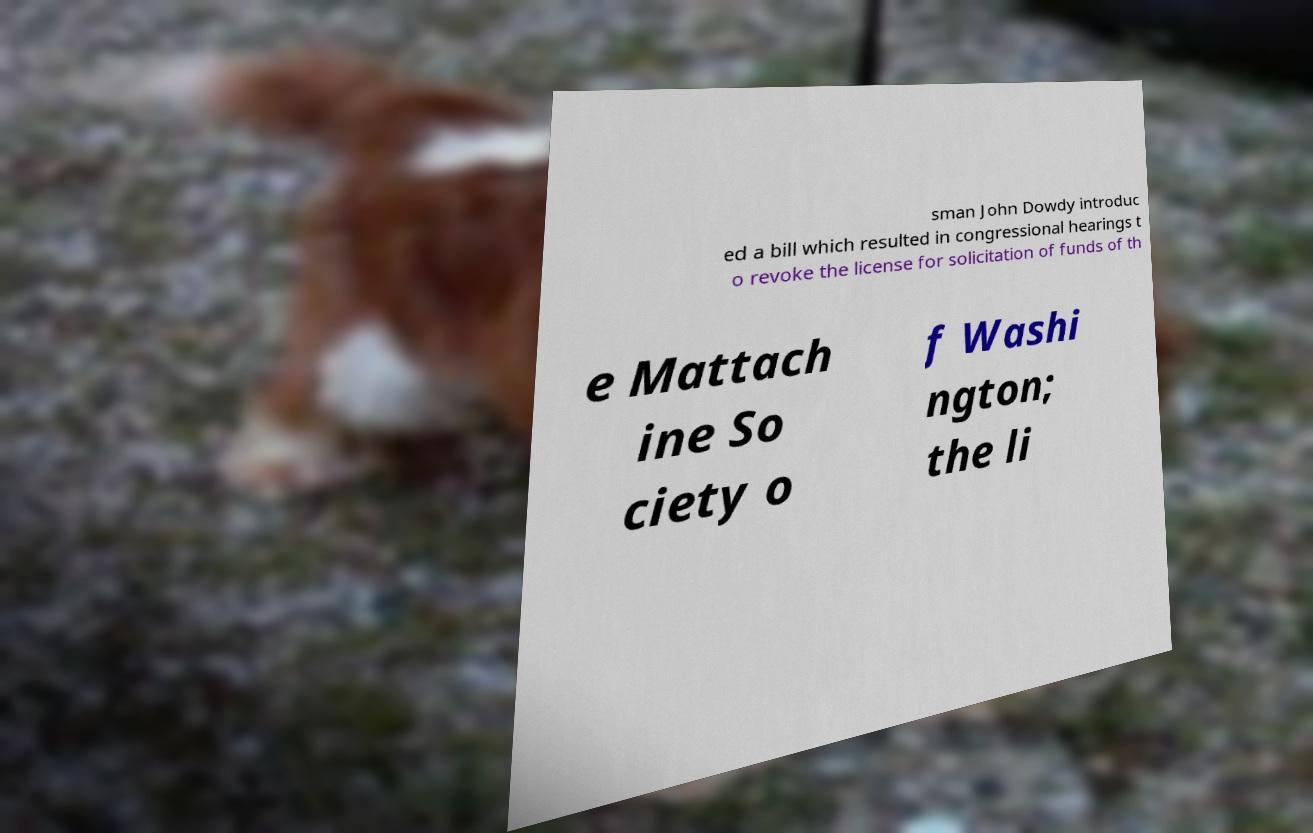Please read and relay the text visible in this image. What does it say? sman John Dowdy introduc ed a bill which resulted in congressional hearings t o revoke the license for solicitation of funds of th e Mattach ine So ciety o f Washi ngton; the li 